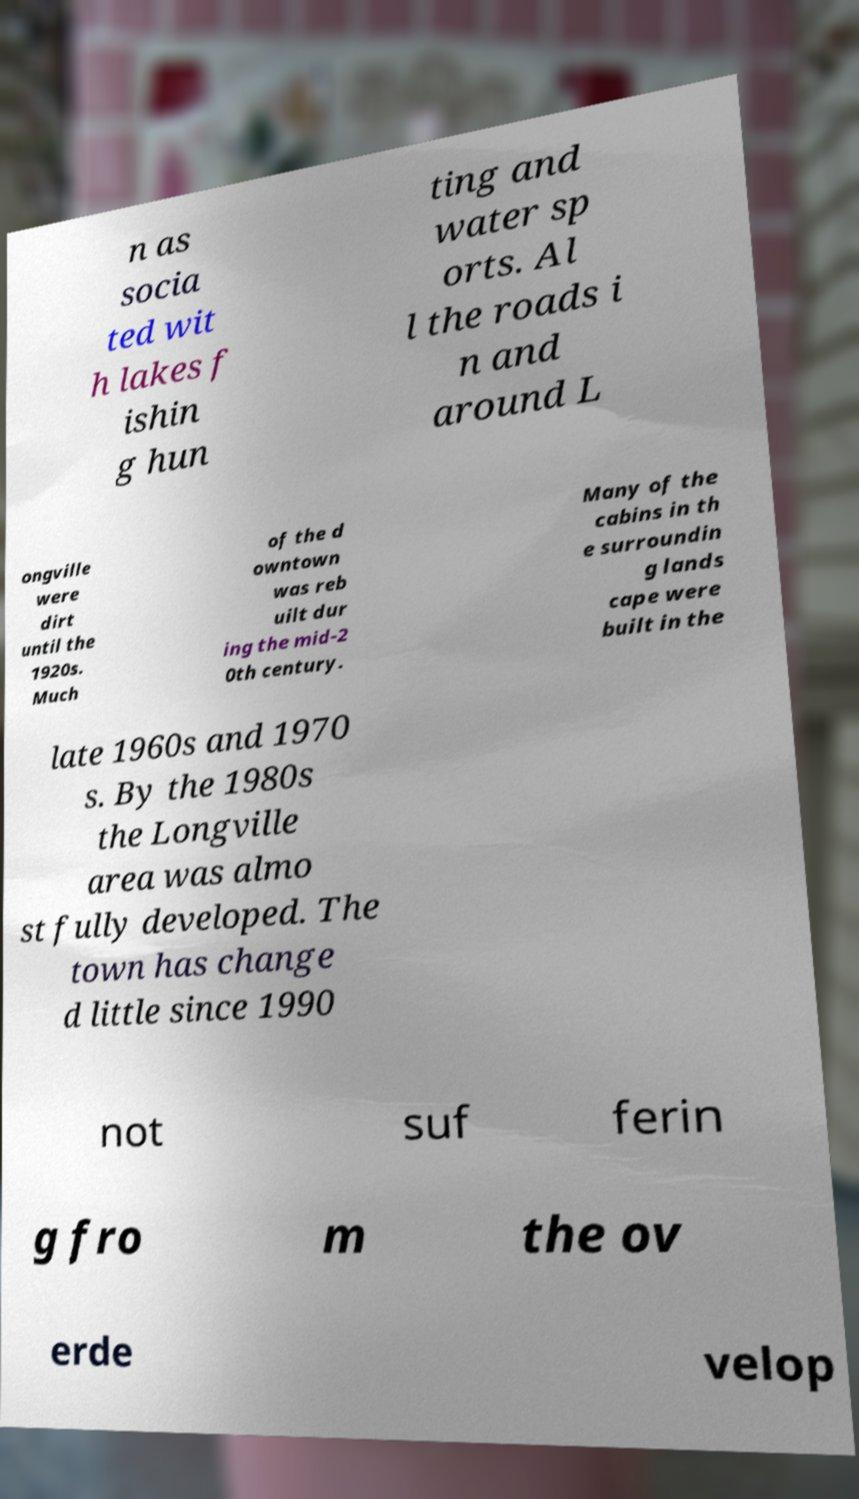There's text embedded in this image that I need extracted. Can you transcribe it verbatim? n as socia ted wit h lakes f ishin g hun ting and water sp orts. Al l the roads i n and around L ongville were dirt until the 1920s. Much of the d owntown was reb uilt dur ing the mid-2 0th century. Many of the cabins in th e surroundin g lands cape were built in the late 1960s and 1970 s. By the 1980s the Longville area was almo st fully developed. The town has change d little since 1990 not suf ferin g fro m the ov erde velop 